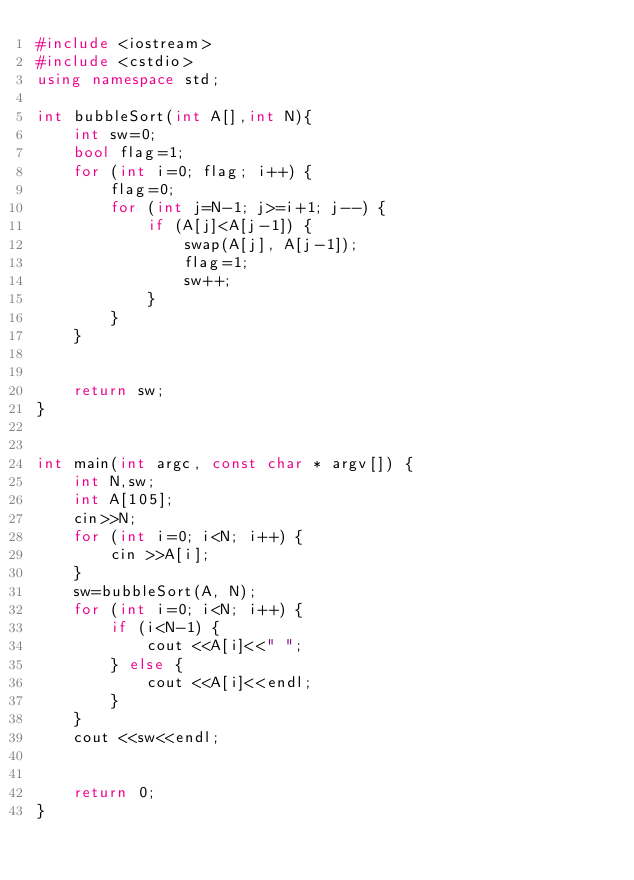<code> <loc_0><loc_0><loc_500><loc_500><_C++_>#include <iostream>
#include <cstdio>
using namespace std;

int bubbleSort(int A[],int N){
    int sw=0;
    bool flag=1;  
    for (int i=0; flag; i++) {
        flag=0;
        for (int j=N-1; j>=i+1; j--) {
            if (A[j]<A[j-1]) {
                swap(A[j], A[j-1]);
                flag=1;
                sw++;
            }
        }
    }
    
   
    return sw;
}


int main(int argc, const char * argv[]) {
    int N,sw;
    int A[105];
    cin>>N;
    for (int i=0; i<N; i++) {
        cin >>A[i];
    }
    sw=bubbleSort(A, N);
    for (int i=0; i<N; i++) {
        if (i<N-1) {
            cout <<A[i]<<" ";
        } else {
            cout <<A[i]<<endl;
        }
    }
    cout <<sw<<endl;
    
    
    return 0;
}

</code> 